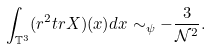<formula> <loc_0><loc_0><loc_500><loc_500>\int _ { \mathbb { T } ^ { 3 } } ( r ^ { 2 } t r X ) ( x ) d x \sim _ { \psi } - \frac { 3 } { \mathcal { N } ^ { 2 } } .</formula> 